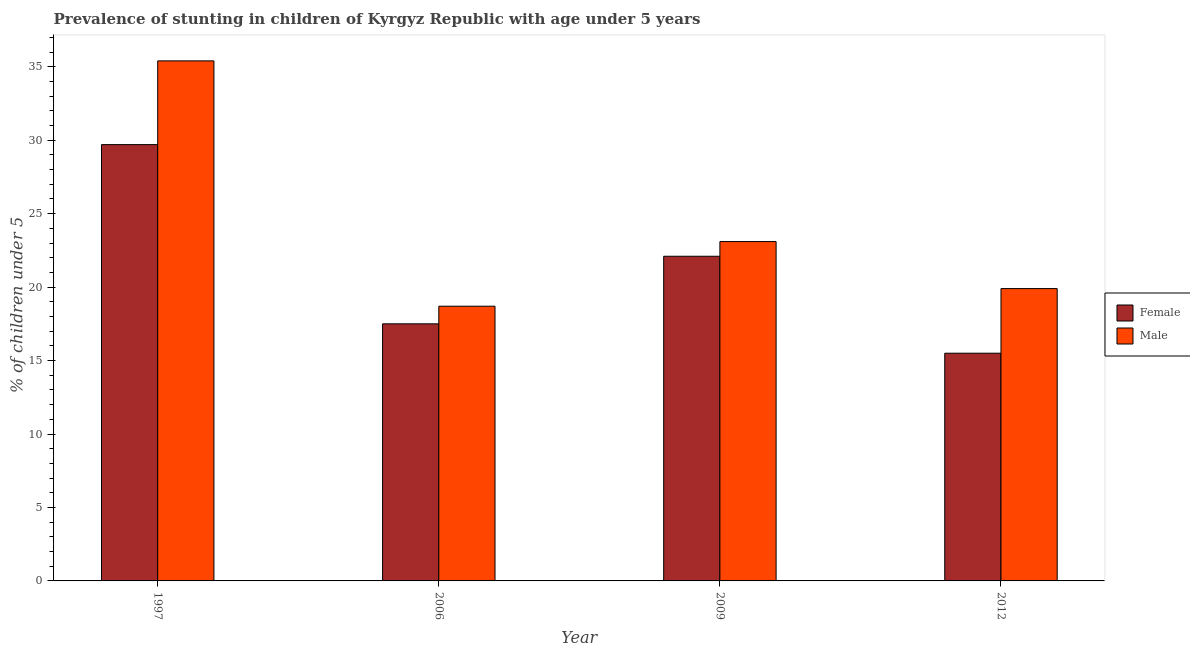How many groups of bars are there?
Provide a succinct answer. 4. Are the number of bars on each tick of the X-axis equal?
Your answer should be very brief. Yes. What is the label of the 1st group of bars from the left?
Provide a short and direct response. 1997. Across all years, what is the maximum percentage of stunted male children?
Give a very brief answer. 35.4. In which year was the percentage of stunted female children maximum?
Provide a succinct answer. 1997. What is the total percentage of stunted male children in the graph?
Your answer should be very brief. 97.1. What is the difference between the percentage of stunted male children in 1997 and that in 2009?
Keep it short and to the point. 12.3. What is the difference between the percentage of stunted female children in 1997 and the percentage of stunted male children in 2009?
Your answer should be compact. 7.6. What is the average percentage of stunted male children per year?
Your answer should be compact. 24.28. In the year 2006, what is the difference between the percentage of stunted male children and percentage of stunted female children?
Offer a terse response. 0. In how many years, is the percentage of stunted male children greater than 2 %?
Your response must be concise. 4. What is the ratio of the percentage of stunted male children in 2006 to that in 2012?
Keep it short and to the point. 0.94. Is the percentage of stunted female children in 2009 less than that in 2012?
Offer a terse response. No. What is the difference between the highest and the second highest percentage of stunted male children?
Ensure brevity in your answer.  12.3. What is the difference between the highest and the lowest percentage of stunted female children?
Keep it short and to the point. 14.2. Are all the bars in the graph horizontal?
Provide a short and direct response. No. How many years are there in the graph?
Keep it short and to the point. 4. Are the values on the major ticks of Y-axis written in scientific E-notation?
Give a very brief answer. No. Does the graph contain any zero values?
Your answer should be compact. No. Does the graph contain grids?
Offer a terse response. No. Where does the legend appear in the graph?
Your answer should be very brief. Center right. How many legend labels are there?
Your answer should be very brief. 2. How are the legend labels stacked?
Ensure brevity in your answer.  Vertical. What is the title of the graph?
Your answer should be compact. Prevalence of stunting in children of Kyrgyz Republic with age under 5 years. Does "Commercial service imports" appear as one of the legend labels in the graph?
Ensure brevity in your answer.  No. What is the label or title of the Y-axis?
Give a very brief answer.  % of children under 5. What is the  % of children under 5 of Female in 1997?
Your answer should be compact. 29.7. What is the  % of children under 5 in Male in 1997?
Your answer should be very brief. 35.4. What is the  % of children under 5 of Male in 2006?
Provide a succinct answer. 18.7. What is the  % of children under 5 of Female in 2009?
Offer a very short reply. 22.1. What is the  % of children under 5 in Male in 2009?
Your response must be concise. 23.1. What is the  % of children under 5 in Female in 2012?
Your response must be concise. 15.5. What is the  % of children under 5 of Male in 2012?
Provide a short and direct response. 19.9. Across all years, what is the maximum  % of children under 5 in Female?
Offer a terse response. 29.7. Across all years, what is the maximum  % of children under 5 of Male?
Give a very brief answer. 35.4. Across all years, what is the minimum  % of children under 5 in Male?
Make the answer very short. 18.7. What is the total  % of children under 5 of Female in the graph?
Make the answer very short. 84.8. What is the total  % of children under 5 in Male in the graph?
Your answer should be compact. 97.1. What is the difference between the  % of children under 5 in Male in 1997 and that in 2006?
Give a very brief answer. 16.7. What is the difference between the  % of children under 5 of Female in 2006 and that in 2012?
Make the answer very short. 2. What is the difference between the  % of children under 5 in Female in 1997 and the  % of children under 5 in Male in 2009?
Keep it short and to the point. 6.6. What is the difference between the  % of children under 5 in Female in 1997 and the  % of children under 5 in Male in 2012?
Give a very brief answer. 9.8. What is the difference between the  % of children under 5 in Female in 2006 and the  % of children under 5 in Male in 2009?
Make the answer very short. -5.6. What is the difference between the  % of children under 5 in Female in 2006 and the  % of children under 5 in Male in 2012?
Your answer should be very brief. -2.4. What is the difference between the  % of children under 5 in Female in 2009 and the  % of children under 5 in Male in 2012?
Your response must be concise. 2.2. What is the average  % of children under 5 in Female per year?
Ensure brevity in your answer.  21.2. What is the average  % of children under 5 in Male per year?
Give a very brief answer. 24.27. In the year 1997, what is the difference between the  % of children under 5 in Female and  % of children under 5 in Male?
Offer a very short reply. -5.7. In the year 2006, what is the difference between the  % of children under 5 in Female and  % of children under 5 in Male?
Keep it short and to the point. -1.2. What is the ratio of the  % of children under 5 of Female in 1997 to that in 2006?
Provide a succinct answer. 1.7. What is the ratio of the  % of children under 5 in Male in 1997 to that in 2006?
Provide a succinct answer. 1.89. What is the ratio of the  % of children under 5 of Female in 1997 to that in 2009?
Offer a terse response. 1.34. What is the ratio of the  % of children under 5 in Male in 1997 to that in 2009?
Make the answer very short. 1.53. What is the ratio of the  % of children under 5 of Female in 1997 to that in 2012?
Your answer should be compact. 1.92. What is the ratio of the  % of children under 5 in Male in 1997 to that in 2012?
Provide a short and direct response. 1.78. What is the ratio of the  % of children under 5 of Female in 2006 to that in 2009?
Make the answer very short. 0.79. What is the ratio of the  % of children under 5 in Male in 2006 to that in 2009?
Keep it short and to the point. 0.81. What is the ratio of the  % of children under 5 in Female in 2006 to that in 2012?
Give a very brief answer. 1.13. What is the ratio of the  % of children under 5 of Male in 2006 to that in 2012?
Offer a very short reply. 0.94. What is the ratio of the  % of children under 5 in Female in 2009 to that in 2012?
Offer a terse response. 1.43. What is the ratio of the  % of children under 5 in Male in 2009 to that in 2012?
Ensure brevity in your answer.  1.16. What is the difference between the highest and the second highest  % of children under 5 in Female?
Offer a very short reply. 7.6. What is the difference between the highest and the second highest  % of children under 5 in Male?
Offer a terse response. 12.3. What is the difference between the highest and the lowest  % of children under 5 in Female?
Your response must be concise. 14.2. What is the difference between the highest and the lowest  % of children under 5 in Male?
Keep it short and to the point. 16.7. 